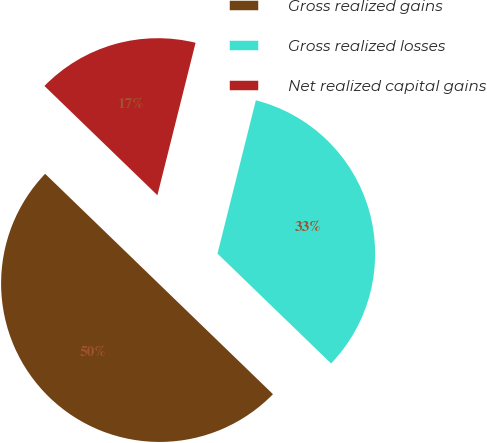Convert chart to OTSL. <chart><loc_0><loc_0><loc_500><loc_500><pie_chart><fcel>Gross realized gains<fcel>Gross realized losses<fcel>Net realized capital gains<nl><fcel>50.0%<fcel>33.33%<fcel>16.67%<nl></chart> 